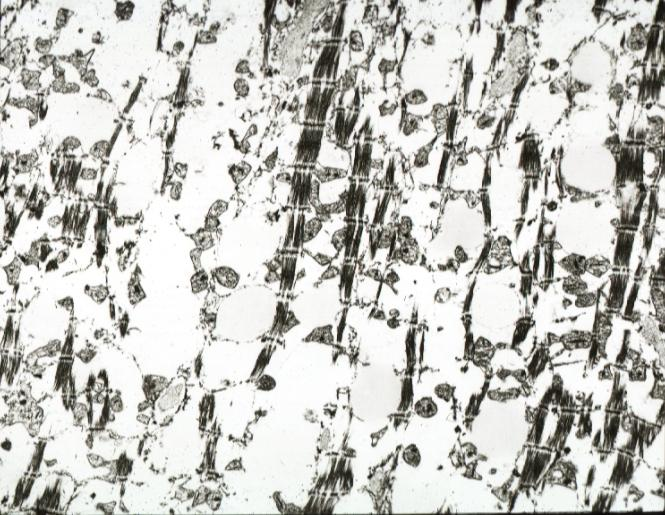what is present?
Answer the question using a single word or phrase. Chronic ischemia 